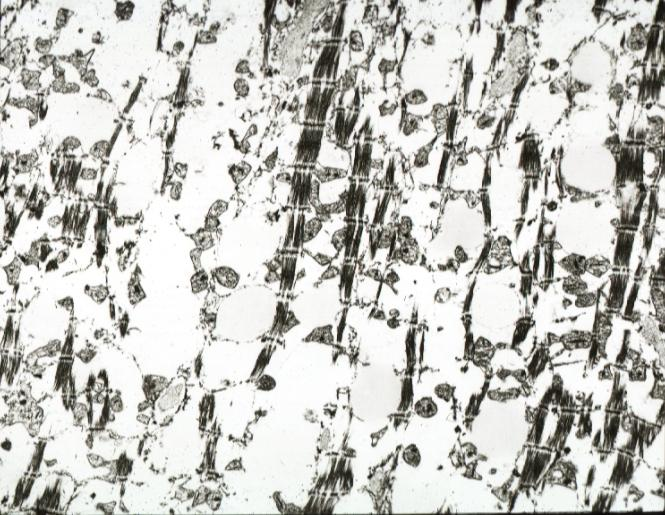what is present?
Answer the question using a single word or phrase. Chronic ischemia 